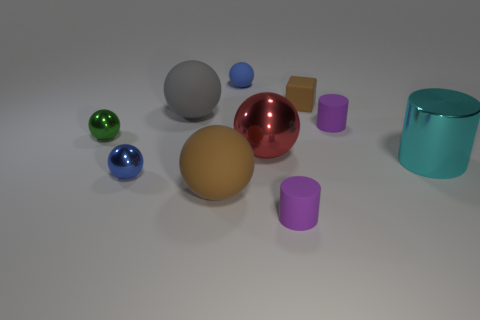There is a blue thing behind the brown rubber cube; is its shape the same as the green object?
Offer a terse response. Yes. Are there more cyan cylinders that are behind the large red shiny thing than blue matte cubes?
Offer a very short reply. No. What is the material of the object that is both to the right of the matte block and behind the red sphere?
Your answer should be compact. Rubber. Is there any other thing that is the same shape as the red object?
Offer a terse response. Yes. What number of objects are both to the right of the large brown sphere and on the left side of the large metal cylinder?
Offer a terse response. 5. What is the green ball made of?
Your response must be concise. Metal. Is the number of small brown rubber cubes that are behind the matte cube the same as the number of small blue spheres?
Your answer should be compact. No. How many large brown rubber things are the same shape as the green metal object?
Give a very brief answer. 1. Is the gray object the same shape as the small brown object?
Make the answer very short. No. How many things are either big metallic objects that are behind the large metallic cylinder or matte balls?
Make the answer very short. 4. 